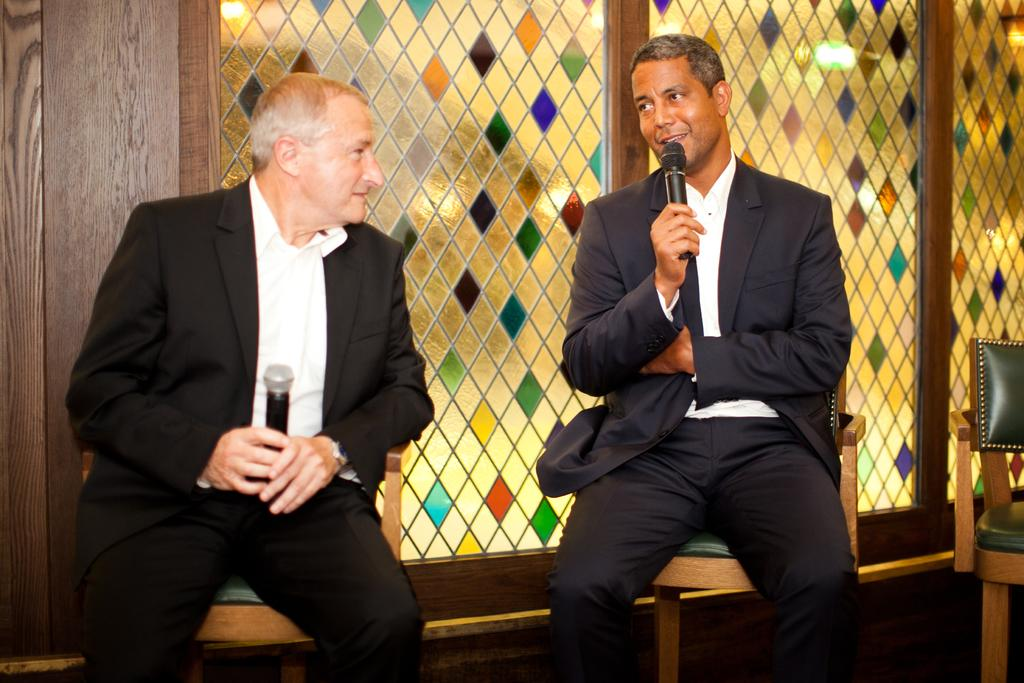How many people are in the image? There are two men in the image. What are the men doing in the image? The men are sitting on chairs and holding microphones. Can you describe any other objects in the image? There is a glass in the image. What type of rod is being used to polish the berries in the image? There is no rod, polishing, or berries present in the image. 